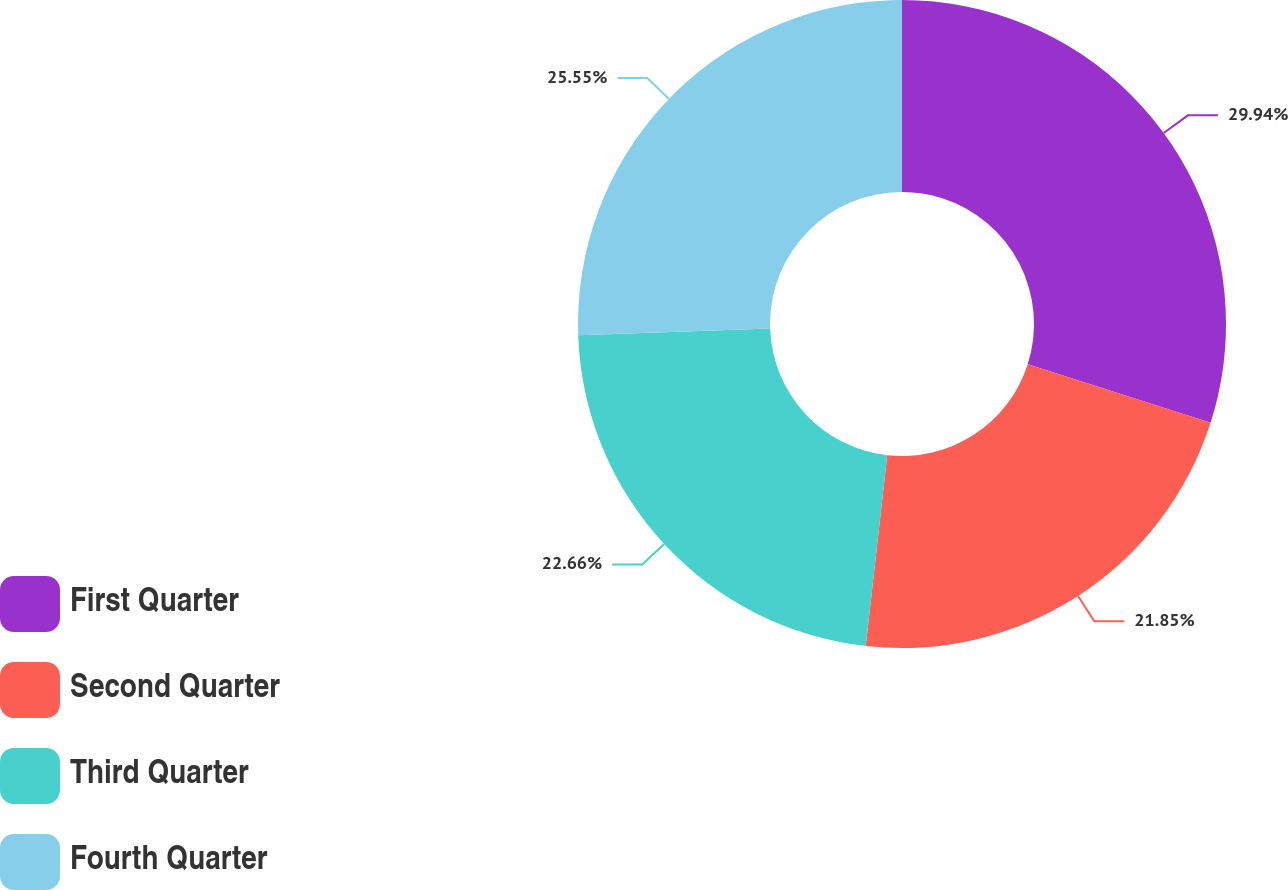Convert chart. <chart><loc_0><loc_0><loc_500><loc_500><pie_chart><fcel>First Quarter<fcel>Second Quarter<fcel>Third Quarter<fcel>Fourth Quarter<nl><fcel>29.93%<fcel>21.85%<fcel>22.66%<fcel>25.55%<nl></chart> 